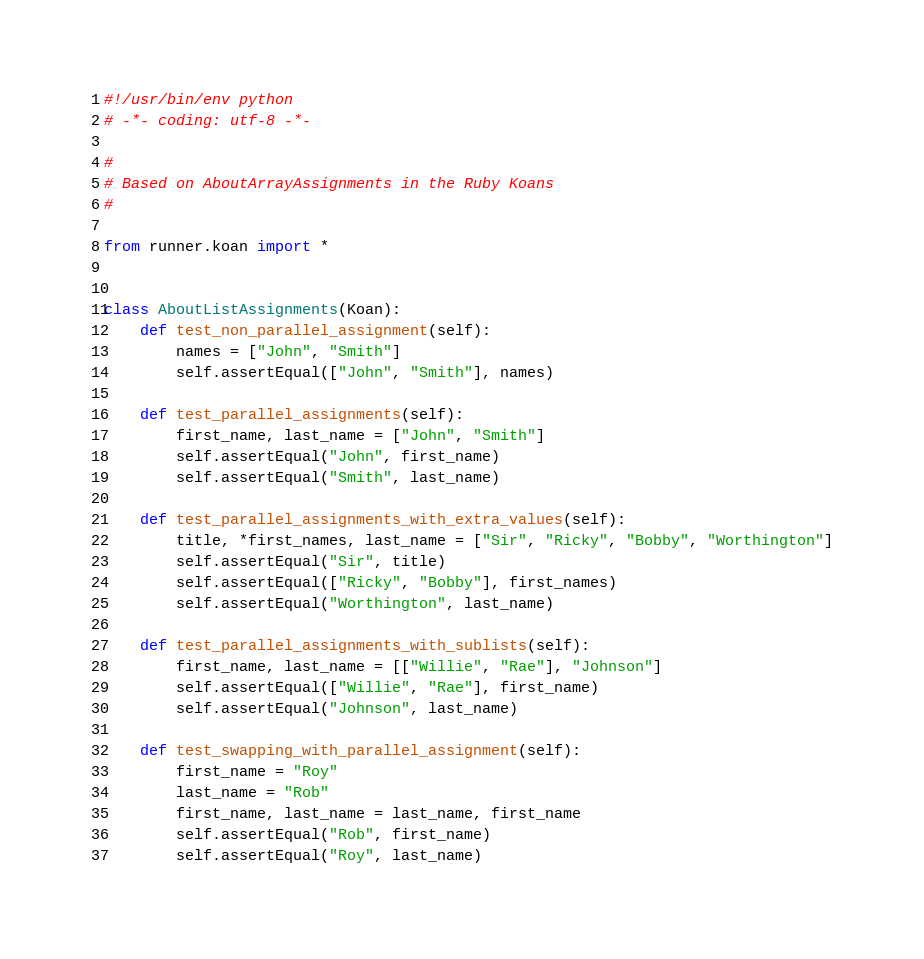Convert code to text. <code><loc_0><loc_0><loc_500><loc_500><_Python_>#!/usr/bin/env python
# -*- coding: utf-8 -*-

#
# Based on AboutArrayAssignments in the Ruby Koans
#

from runner.koan import *


class AboutListAssignments(Koan):
    def test_non_parallel_assignment(self):
        names = ["John", "Smith"]
        self.assertEqual(["John", "Smith"], names)

    def test_parallel_assignments(self):
        first_name, last_name = ["John", "Smith"]
        self.assertEqual("John", first_name)
        self.assertEqual("Smith", last_name)

    def test_parallel_assignments_with_extra_values(self):
        title, *first_names, last_name = ["Sir", "Ricky", "Bobby", "Worthington"]
        self.assertEqual("Sir", title)
        self.assertEqual(["Ricky", "Bobby"], first_names)
        self.assertEqual("Worthington", last_name)

    def test_parallel_assignments_with_sublists(self):
        first_name, last_name = [["Willie", "Rae"], "Johnson"]
        self.assertEqual(["Willie", "Rae"], first_name)
        self.assertEqual("Johnson", last_name)

    def test_swapping_with_parallel_assignment(self):
        first_name = "Roy"
        last_name = "Rob"
        first_name, last_name = last_name, first_name
        self.assertEqual("Rob", first_name)
        self.assertEqual("Roy", last_name)
</code> 